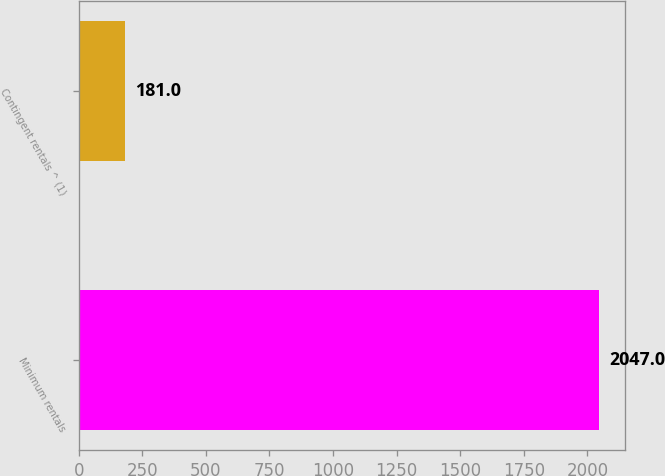Convert chart. <chart><loc_0><loc_0><loc_500><loc_500><bar_chart><fcel>Minimum rentals<fcel>Contingent rentals ^ (1)<nl><fcel>2047<fcel>181<nl></chart> 